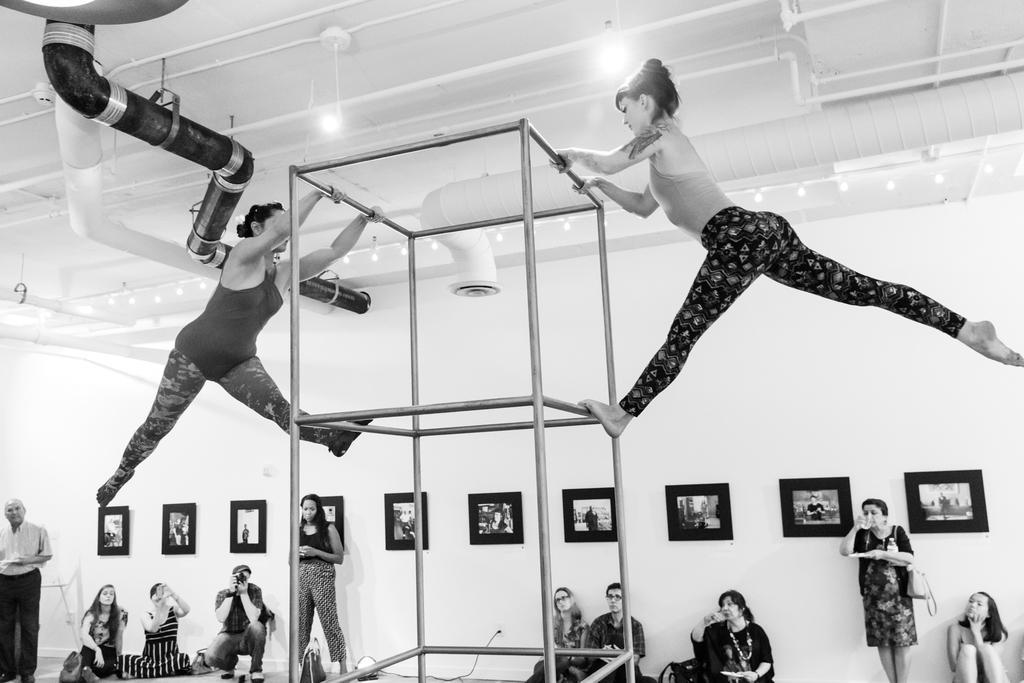Please provide a concise description of this image. This image is a black and white image. This image is taken indoors. At the top of the image there is a roof. There are a few lights. There are many iron bars and there are a few pipelines. At the bottom of the image there is floor. In the background there is a wall with many picture frames on it. A few people are sitting and a few are standing. In the middle of the image two girls are doing gymnastics on the stand which is made of metal rods. 